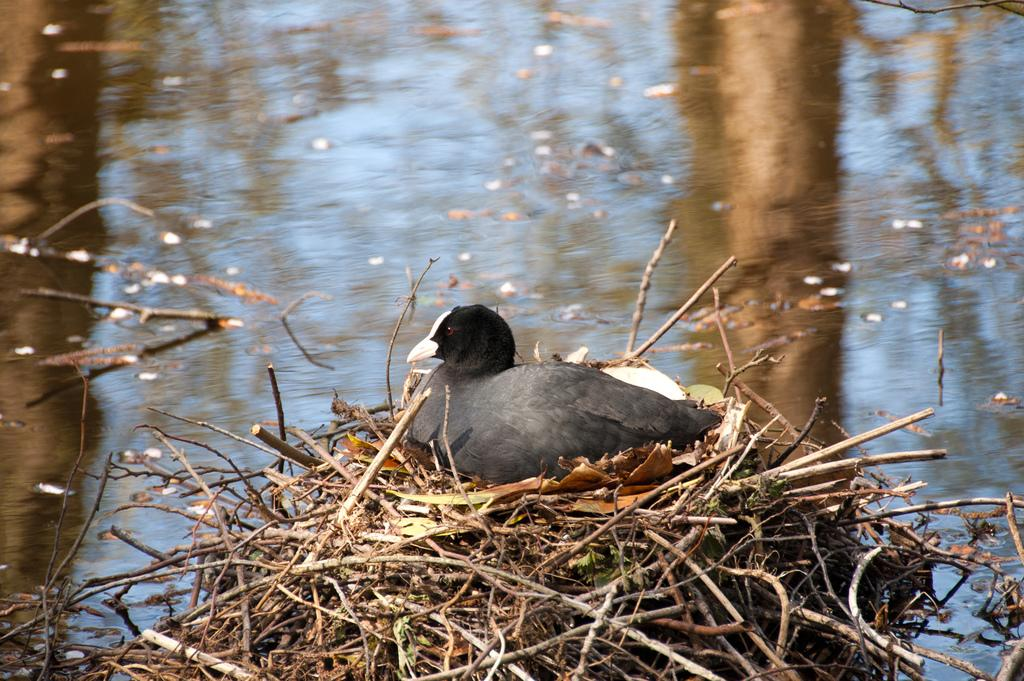What type of animal can be seen in the image? There is a bird in the image. Where is the bird located in the image? The bird is sitting on a nest. What is the nest made of in the image? The nest appears to be built with stems. What can be observed in the background of the image? There is water flowing in the image. What type of hat is the bird wearing in the image? There is no hat present in the image; the bird is sitting on a nest. What advertisement can be seen in the image? There is no advertisement present in the image; it features a bird sitting on a nest made of stems with water flowing in the background. 